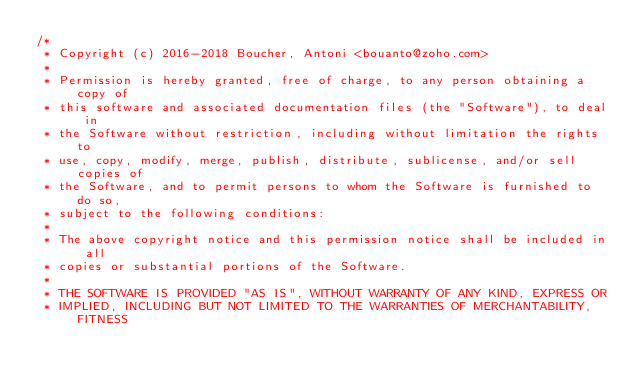<code> <loc_0><loc_0><loc_500><loc_500><_Rust_>/*
 * Copyright (c) 2016-2018 Boucher, Antoni <bouanto@zoho.com>
 *
 * Permission is hereby granted, free of charge, to any person obtaining a copy of
 * this software and associated documentation files (the "Software"), to deal in
 * the Software without restriction, including without limitation the rights to
 * use, copy, modify, merge, publish, distribute, sublicense, and/or sell copies of
 * the Software, and to permit persons to whom the Software is furnished to do so,
 * subject to the following conditions:
 *
 * The above copyright notice and this permission notice shall be included in all
 * copies or substantial portions of the Software.
 *
 * THE SOFTWARE IS PROVIDED "AS IS", WITHOUT WARRANTY OF ANY KIND, EXPRESS OR
 * IMPLIED, INCLUDING BUT NOT LIMITED TO THE WARRANTIES OF MERCHANTABILITY, FITNESS</code> 